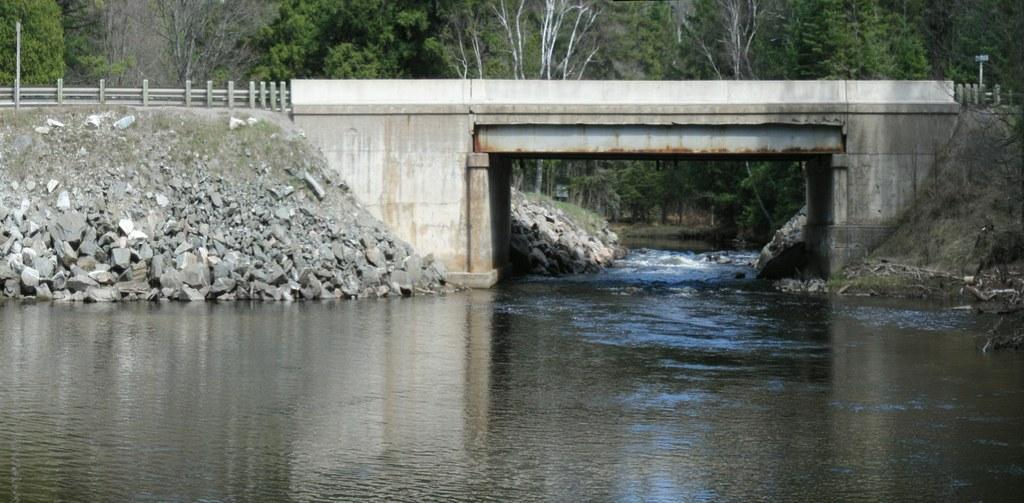In one or two sentences, can you explain what this image depicts? Here in this picture we can see water present all over there and we can see a bridge present over there and we can see plants and trees present all over there and on the left side we can see stones present over there. 